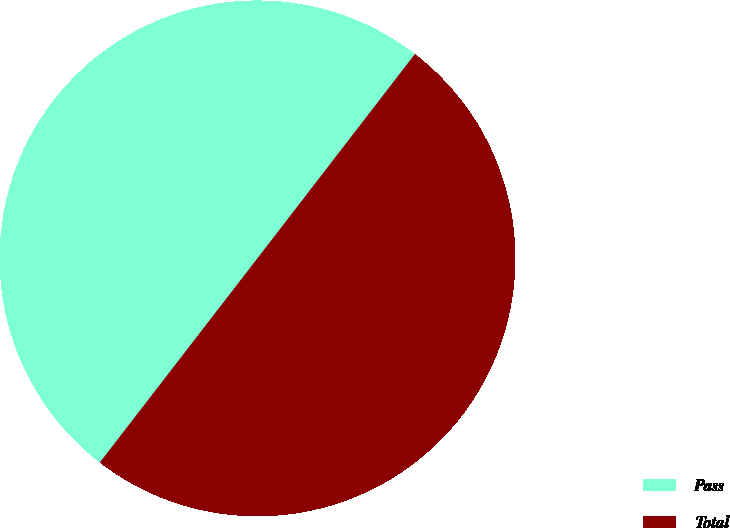Convert chart. <chart><loc_0><loc_0><loc_500><loc_500><pie_chart><fcel>Pass<fcel>Total<nl><fcel>49.99%<fcel>50.01%<nl></chart> 